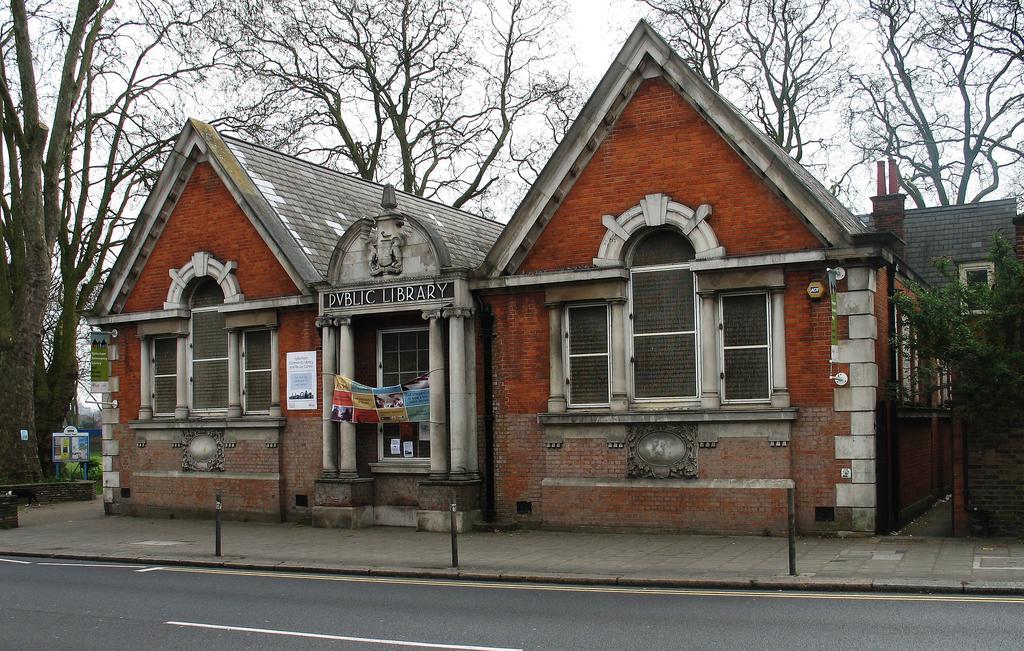How would you summarize this image in a sentence or two? As we can see in the image there are houses, windows, trees, banner and sky. 